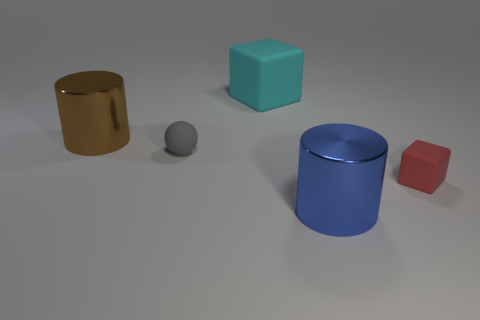Are there an equal number of rubber blocks that are to the left of the red matte object and small green balls?
Offer a very short reply. No. Do the cyan object and the gray rubber ball have the same size?
Offer a terse response. No. There is a object that is both behind the small red block and to the right of the tiny rubber ball; what is it made of?
Give a very brief answer. Rubber. What number of other things are the same shape as the tiny red matte thing?
Provide a succinct answer. 1. What material is the block behind the tiny gray object?
Provide a succinct answer. Rubber. Are there fewer brown metal cylinders to the right of the cyan rubber thing than small blue metal things?
Make the answer very short. No. Does the brown object have the same shape as the large blue object?
Make the answer very short. Yes. Is there any other thing that has the same shape as the gray thing?
Your answer should be compact. No. Are there any blue shiny cylinders?
Your answer should be compact. Yes. Is the shape of the red thing the same as the big matte thing left of the red matte cube?
Your answer should be very brief. Yes. 